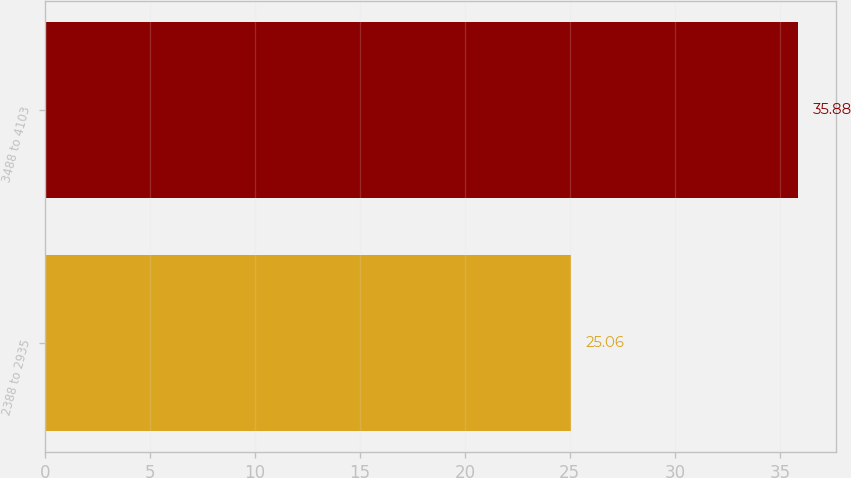Convert chart. <chart><loc_0><loc_0><loc_500><loc_500><bar_chart><fcel>2388 to 2935<fcel>3488 to 4103<nl><fcel>25.06<fcel>35.88<nl></chart> 